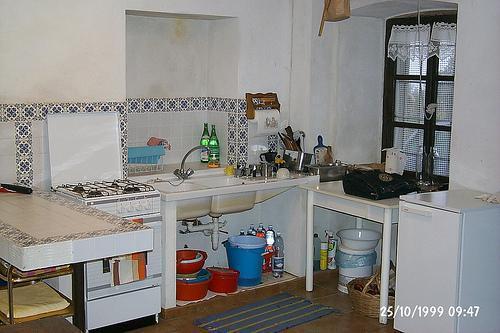How many bottles are behind the sink?
Give a very brief answer. 2. 